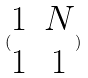Convert formula to latex. <formula><loc_0><loc_0><loc_500><loc_500>( \begin{matrix} 1 & N \\ 1 & 1 \end{matrix} )</formula> 